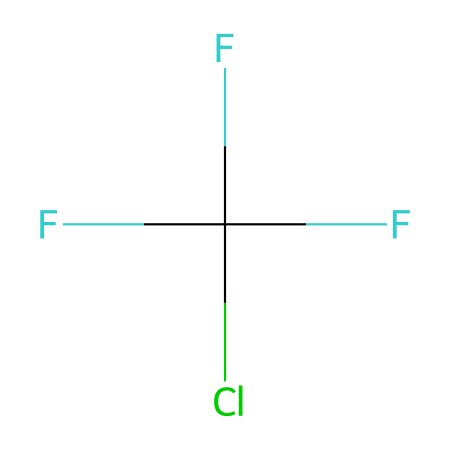What is the total number of carbon atoms in this compound? The SMILES notation indicates "C" followed by another character, which signifies there is one carbon atom present.
Answer: 1 How many fluorine atoms are present in this molecule? The SMILES notation has "F" three times, indicating the presence of three fluorine atoms.
Answer: 3 What type of chemical is represented by this structure? The presence of chlorine, fluorine, and carbon in the structure categorizes it as a chlorofluorocarbon (CFC).
Answer: chlorofluorocarbon What effect does this compound have on the ozone layer? Chlorofluorocarbons are known for their destructive effect on ozone due to the release of chlorine atoms upon UV radiation exposure.
Answer: depletion How many atoms are in total in this molecule? The molecule consists of 1 Carbon, 1 Chlorine, and 3 Fluorines, leading to a total of 5 atoms.
Answer: 5 What is the bond type between the carbon and chlorine in this compound? The carbon-chlorine bond is a single covalent bond, as indicated by the absence of any indication of multiple bonds in the SMILES notation.
Answer: single Which atom in this compound is responsible for its reactivity towards ozone? The chlorine atom is the reactive species in chlorofluorocarbons that contributes to ozone depletion.
Answer: chlorine 